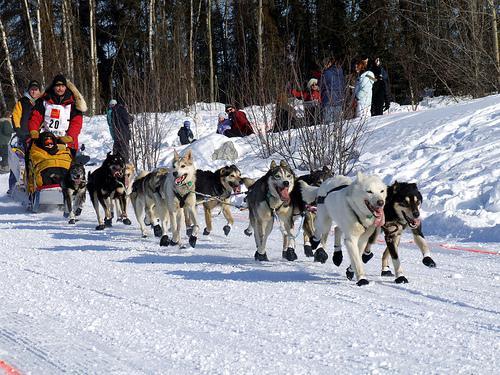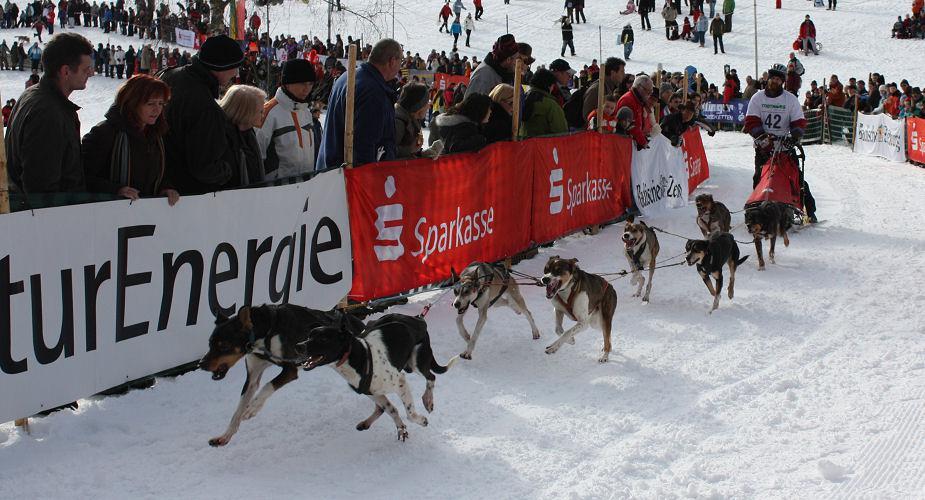The first image is the image on the left, the second image is the image on the right. Considering the images on both sides, is "The sled dogs in the images are running in the same general direction." valid? Answer yes or no. No. 